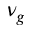Convert formula to latex. <formula><loc_0><loc_0><loc_500><loc_500>\nu _ { g }</formula> 